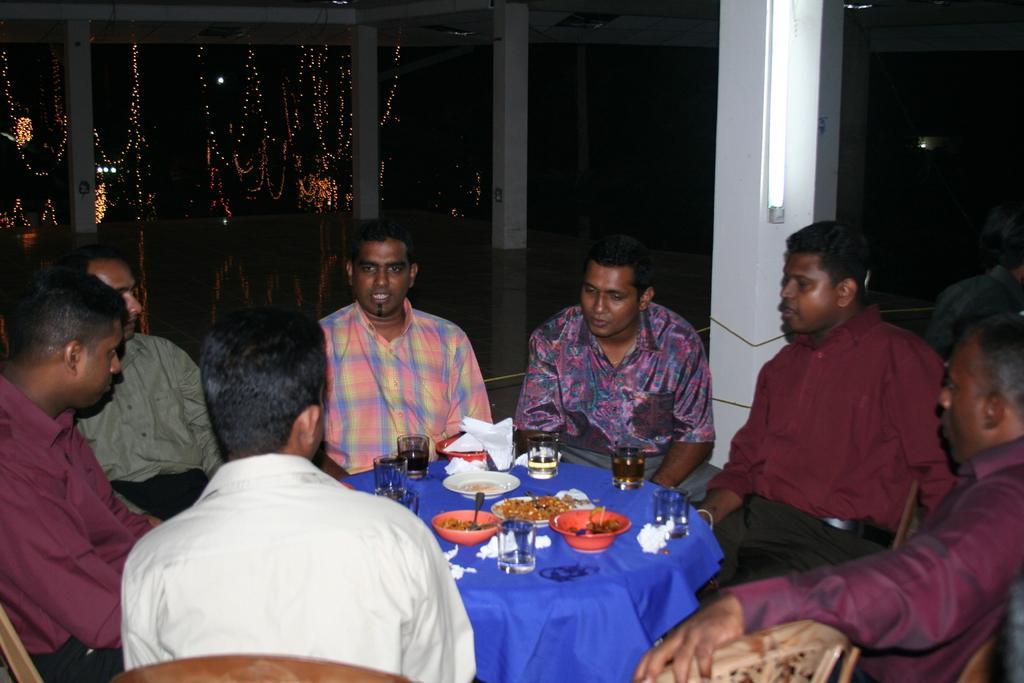How would you summarize this image in a sentence or two? In this picture we can see group of people sitting on chair and in front of them we have table and on table we can see glass, tissue paper, plate, bowls, spoon , some food and in background we can see pillars, lights, decorative lights. 